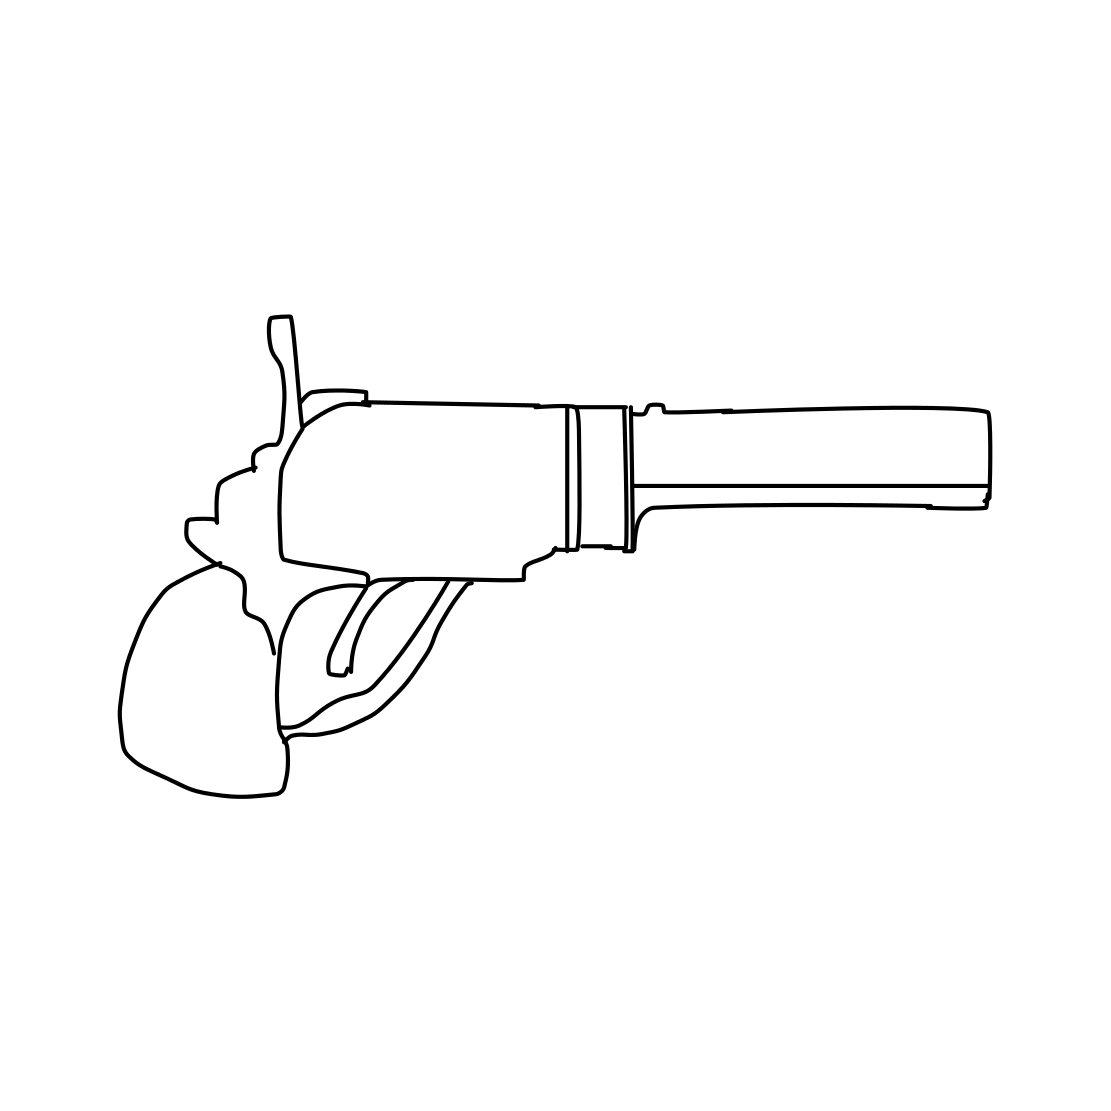Is there a sketchy revolver in the picture? Indeed, the image displays a simple line drawing of a revolver. The sketch is minimalistic, capturing the essential shape and components of the firearm, like the barrel, cylinder, and grip. 